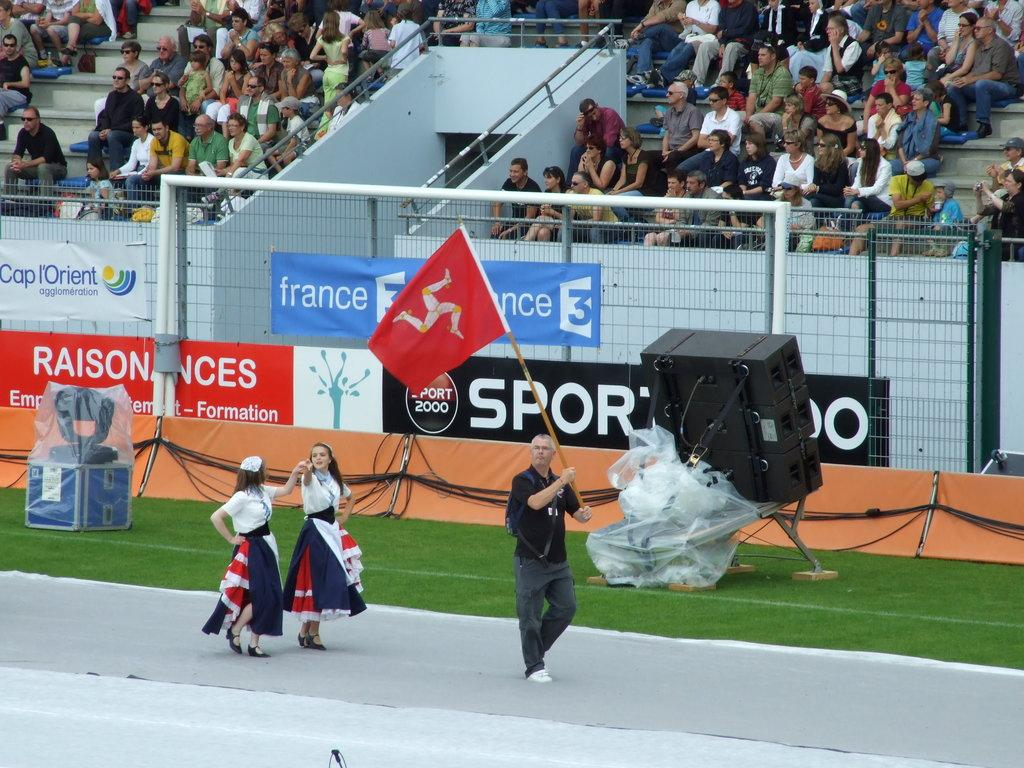<image>
Write a terse but informative summary of the picture. A man waves a red flag at an event with a banner for France up. 